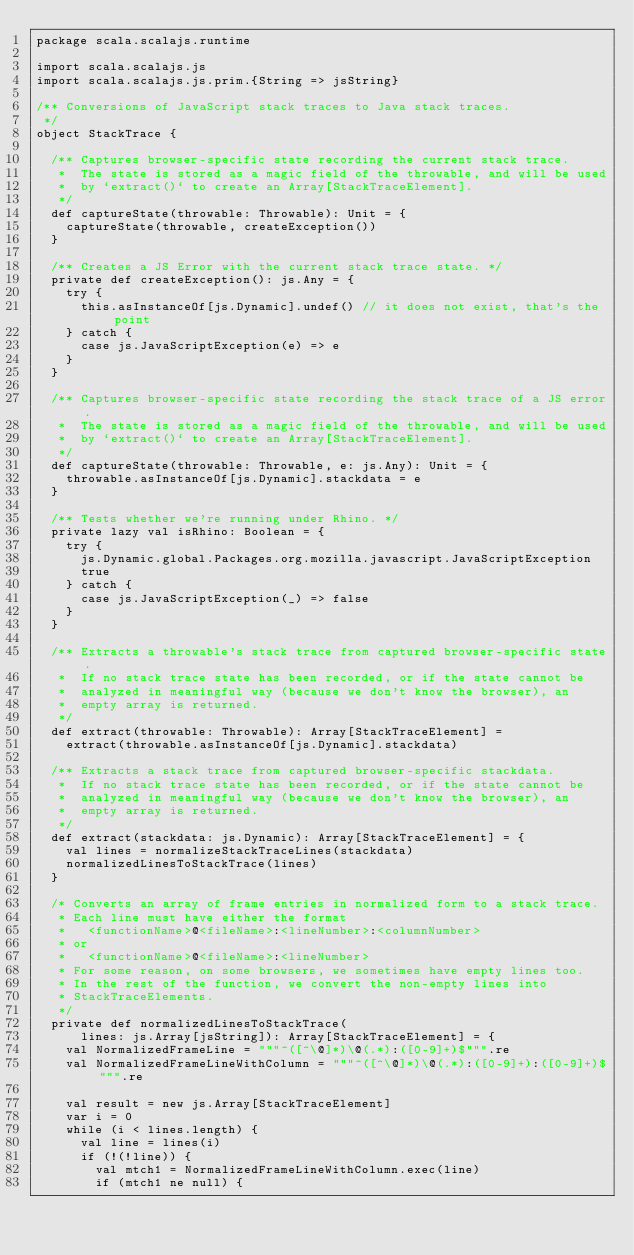<code> <loc_0><loc_0><loc_500><loc_500><_Scala_>package scala.scalajs.runtime

import scala.scalajs.js
import scala.scalajs.js.prim.{String => jsString}

/** Conversions of JavaScript stack traces to Java stack traces.
 */
object StackTrace {

  /** Captures browser-specific state recording the current stack trace.
   *  The state is stored as a magic field of the throwable, and will be used
   *  by `extract()` to create an Array[StackTraceElement].
   */
  def captureState(throwable: Throwable): Unit = {
    captureState(throwable, createException())
  }

  /** Creates a JS Error with the current stack trace state. */
  private def createException(): js.Any = {
    try {
      this.asInstanceOf[js.Dynamic].undef() // it does not exist, that's the point
    } catch {
      case js.JavaScriptException(e) => e
    }
  }

  /** Captures browser-specific state recording the stack trace of a JS error.
   *  The state is stored as a magic field of the throwable, and will be used
   *  by `extract()` to create an Array[StackTraceElement].
   */
  def captureState(throwable: Throwable, e: js.Any): Unit = {
    throwable.asInstanceOf[js.Dynamic].stackdata = e
  }

  /** Tests whether we're running under Rhino. */
  private lazy val isRhino: Boolean = {
    try {
      js.Dynamic.global.Packages.org.mozilla.javascript.JavaScriptException
      true
    } catch {
      case js.JavaScriptException(_) => false
    }
  }

  /** Extracts a throwable's stack trace from captured browser-specific state.
   *  If no stack trace state has been recorded, or if the state cannot be
   *  analyzed in meaningful way (because we don't know the browser), an
   *  empty array is returned.
   */
  def extract(throwable: Throwable): Array[StackTraceElement] =
    extract(throwable.asInstanceOf[js.Dynamic].stackdata)

  /** Extracts a stack trace from captured browser-specific stackdata.
   *  If no stack trace state has been recorded, or if the state cannot be
   *  analyzed in meaningful way (because we don't know the browser), an
   *  empty array is returned.
   */
  def extract(stackdata: js.Dynamic): Array[StackTraceElement] = {
    val lines = normalizeStackTraceLines(stackdata)
    normalizedLinesToStackTrace(lines)
  }

  /* Converts an array of frame entries in normalized form to a stack trace.
   * Each line must have either the format
   *   <functionName>@<fileName>:<lineNumber>:<columnNumber>
   * or
   *   <functionName>@<fileName>:<lineNumber>
   * For some reason, on some browsers, we sometimes have empty lines too.
   * In the rest of the function, we convert the non-empty lines into
   * StackTraceElements.
   */
  private def normalizedLinesToStackTrace(
      lines: js.Array[jsString]): Array[StackTraceElement] = {
    val NormalizedFrameLine = """^([^\@]*)\@(.*):([0-9]+)$""".re
    val NormalizedFrameLineWithColumn = """^([^\@]*)\@(.*):([0-9]+):([0-9]+)$""".re

    val result = new js.Array[StackTraceElement]
    var i = 0
    while (i < lines.length) {
      val line = lines(i)
      if (!(!line)) {
        val mtch1 = NormalizedFrameLineWithColumn.exec(line)
        if (mtch1 ne null) {</code> 